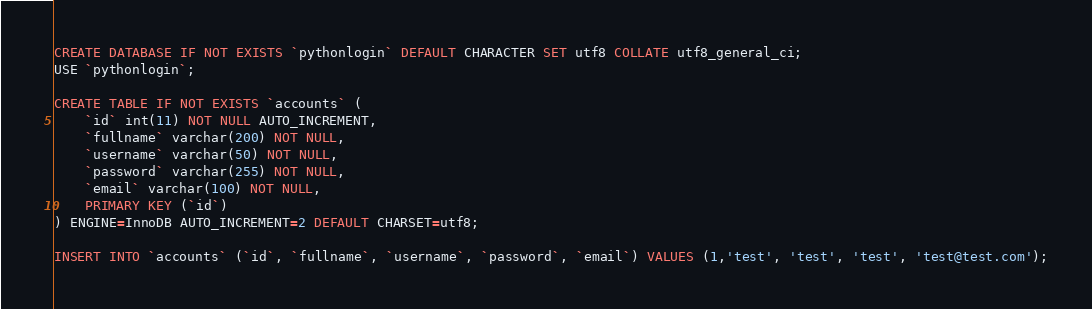<code> <loc_0><loc_0><loc_500><loc_500><_SQL_>CREATE DATABASE IF NOT EXISTS `pythonlogin` DEFAULT CHARACTER SET utf8 COLLATE utf8_general_ci;
USE `pythonlogin`;

CREATE TABLE IF NOT EXISTS `accounts` (
	`id` int(11) NOT NULL AUTO_INCREMENT,
    `fullname` varchar(200) NOT NULL,
  	`username` varchar(50) NOT NULL,
  	`password` varchar(255) NOT NULL,
  	`email` varchar(100) NOT NULL,
    PRIMARY KEY (`id`)
) ENGINE=InnoDB AUTO_INCREMENT=2 DEFAULT CHARSET=utf8;

INSERT INTO `accounts` (`id`, `fullname`, `username`, `password`, `email`) VALUES (1,'test', 'test', 'test', 'test@test.com');

</code> 